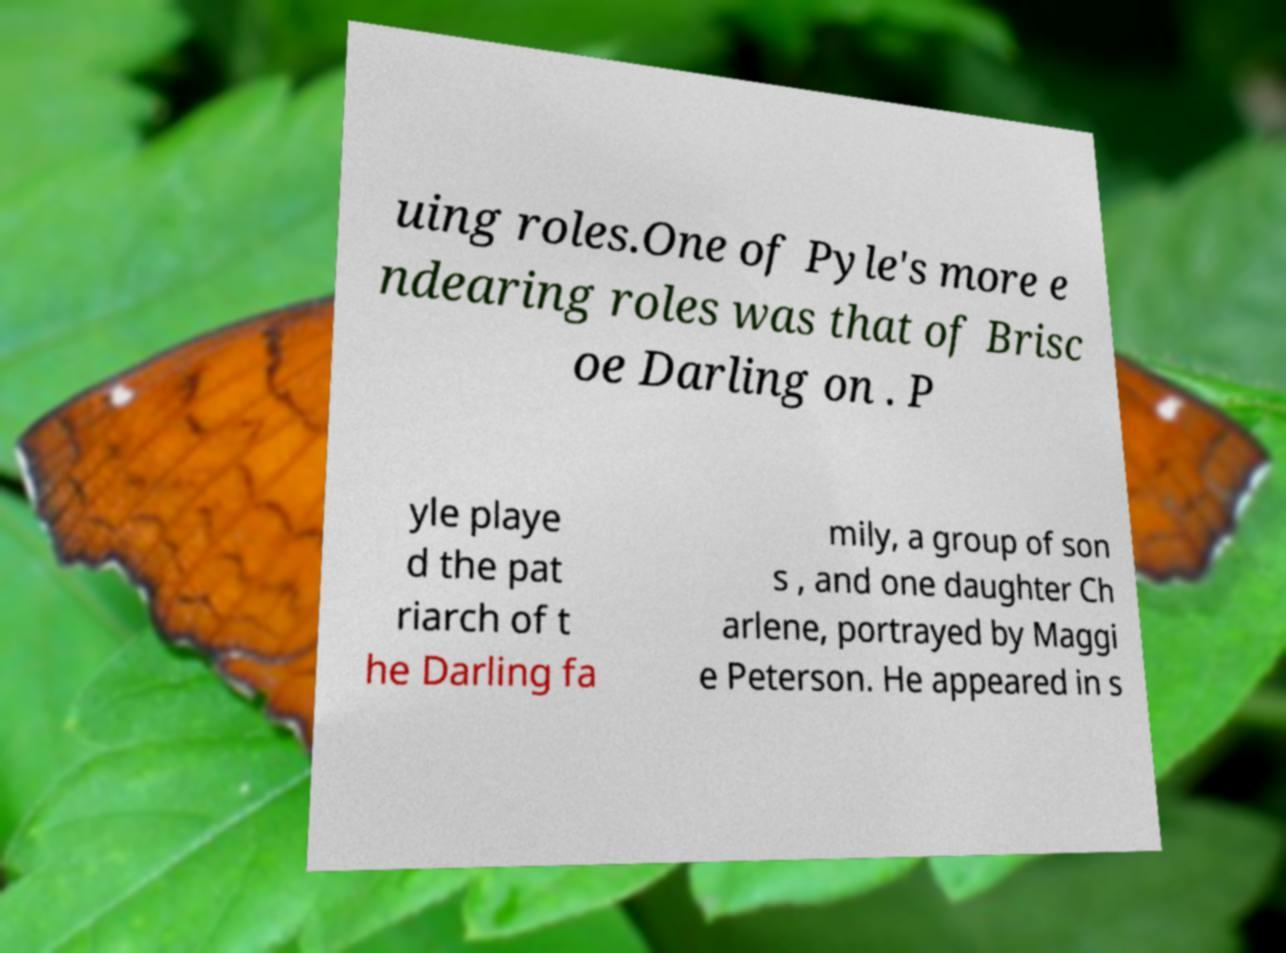What messages or text are displayed in this image? I need them in a readable, typed format. uing roles.One of Pyle's more e ndearing roles was that of Brisc oe Darling on . P yle playe d the pat riarch of t he Darling fa mily, a group of son s , and one daughter Ch arlene, portrayed by Maggi e Peterson. He appeared in s 